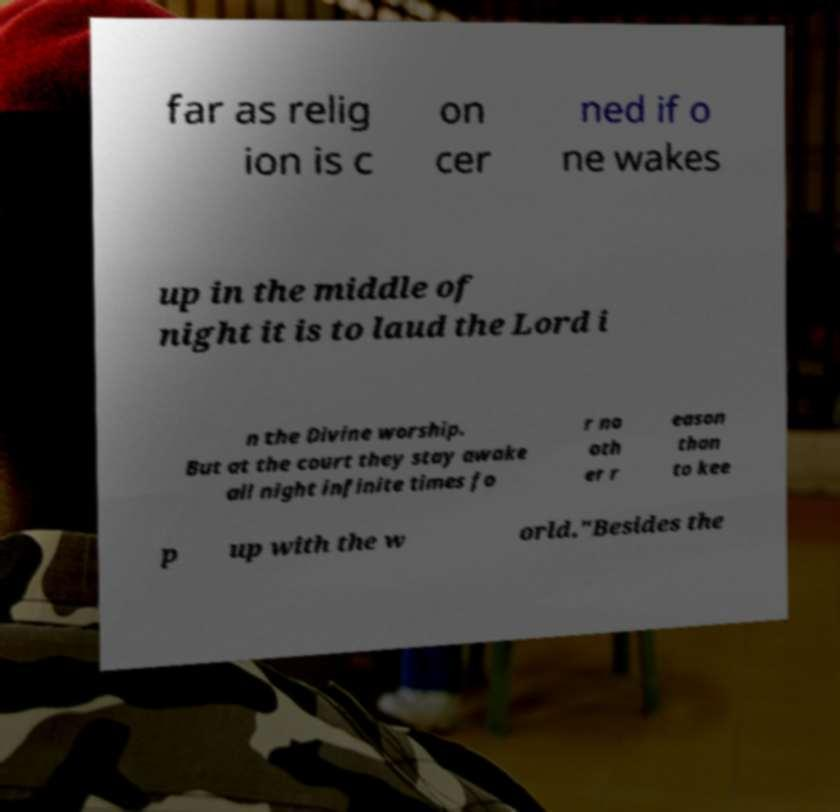Could you extract and type out the text from this image? far as relig ion is c on cer ned if o ne wakes up in the middle of night it is to laud the Lord i n the Divine worship. But at the court they stay awake all night infinite times fo r no oth er r eason than to kee p up with the w orld."Besides the 